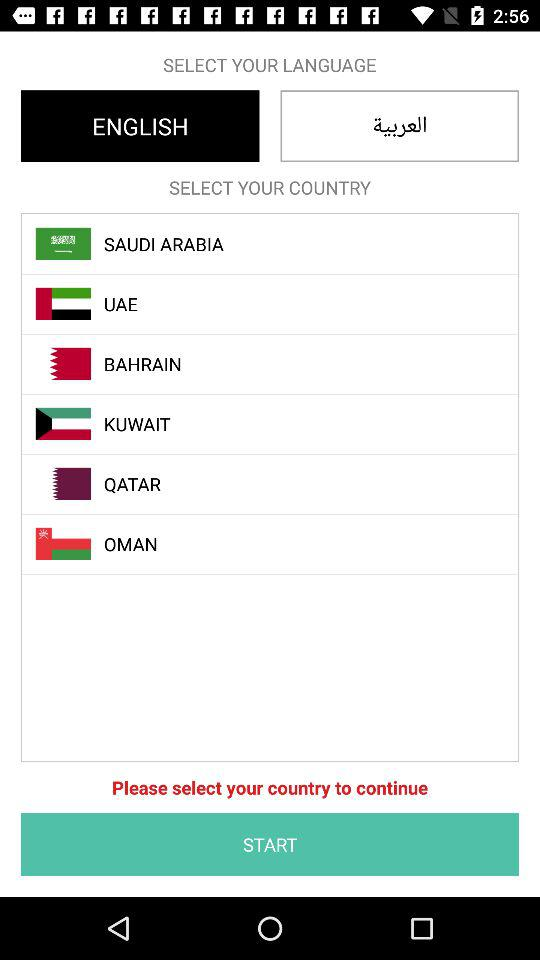How many countries are available to select?
Answer the question using a single word or phrase. 6 